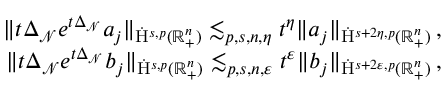<formula> <loc_0><loc_0><loc_500><loc_500>\begin{array} { r } { \| t \Delta _ { \mathcal { N } } e ^ { t \Delta _ { \mathcal { N } } } a _ { j } \| _ { \dot { H } ^ { s , p } ( \mathbb { R } _ { + } ^ { n } ) } \lesssim _ { p , s , n , \eta } t ^ { \eta } \| a _ { j } \| _ { \dot { H } ^ { s + 2 \eta , p } ( \mathbb { R } _ { + } ^ { n } ) } \, , } \\ { \| t \Delta _ { \mathcal { N } } e ^ { t \Delta _ { \mathcal { N } } } b _ { j } \| _ { \dot { H } ^ { s , p } ( \mathbb { R } _ { + } ^ { n } ) } \lesssim _ { p , s , n , \varepsilon } t ^ { \varepsilon } \| b _ { j } \| _ { \dot { H } ^ { s + 2 \varepsilon , p } ( \mathbb { R } _ { + } ^ { n } ) } \, , } \end{array}</formula> 